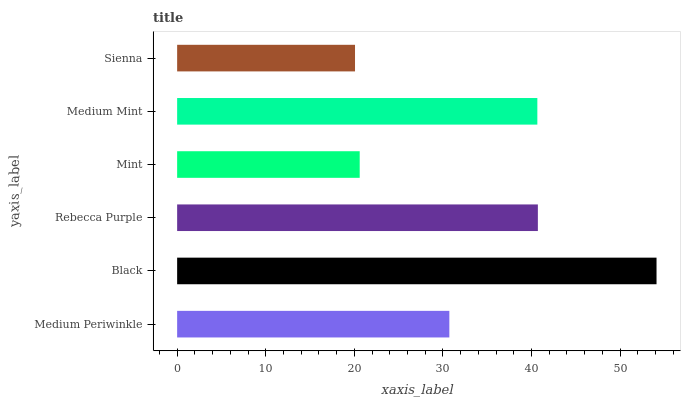Is Sienna the minimum?
Answer yes or no. Yes. Is Black the maximum?
Answer yes or no. Yes. Is Rebecca Purple the minimum?
Answer yes or no. No. Is Rebecca Purple the maximum?
Answer yes or no. No. Is Black greater than Rebecca Purple?
Answer yes or no. Yes. Is Rebecca Purple less than Black?
Answer yes or no. Yes. Is Rebecca Purple greater than Black?
Answer yes or no. No. Is Black less than Rebecca Purple?
Answer yes or no. No. Is Medium Mint the high median?
Answer yes or no. Yes. Is Medium Periwinkle the low median?
Answer yes or no. Yes. Is Black the high median?
Answer yes or no. No. Is Rebecca Purple the low median?
Answer yes or no. No. 